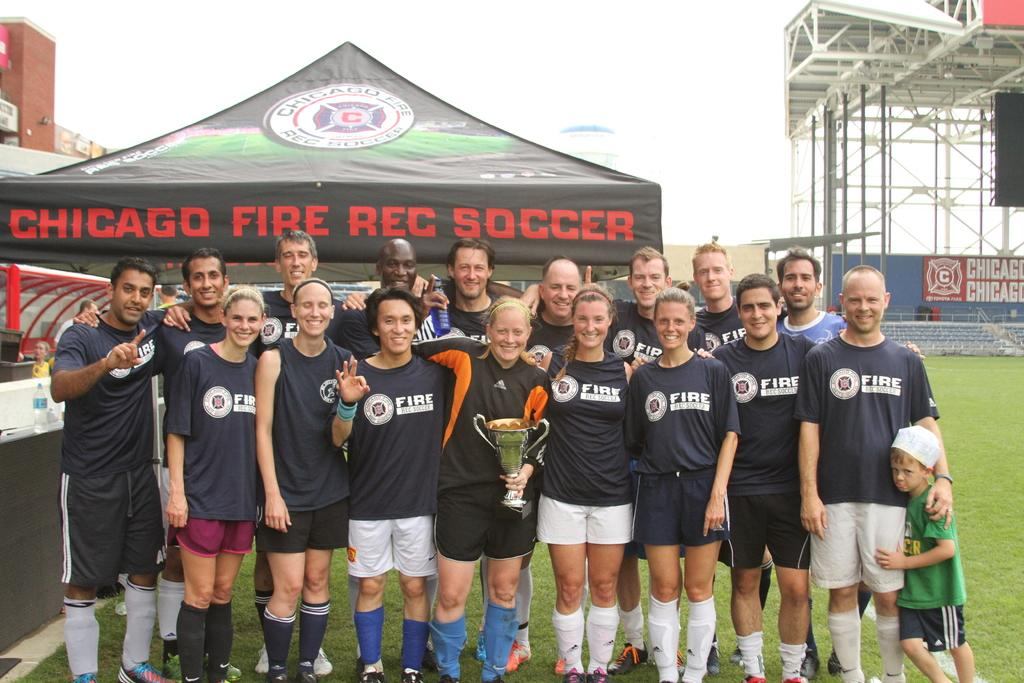<image>
Describe the image concisely. The Chicago Fire Rec Soccer team poses with a trophy. 